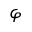Convert formula to latex. <formula><loc_0><loc_0><loc_500><loc_500>\varphi</formula> 